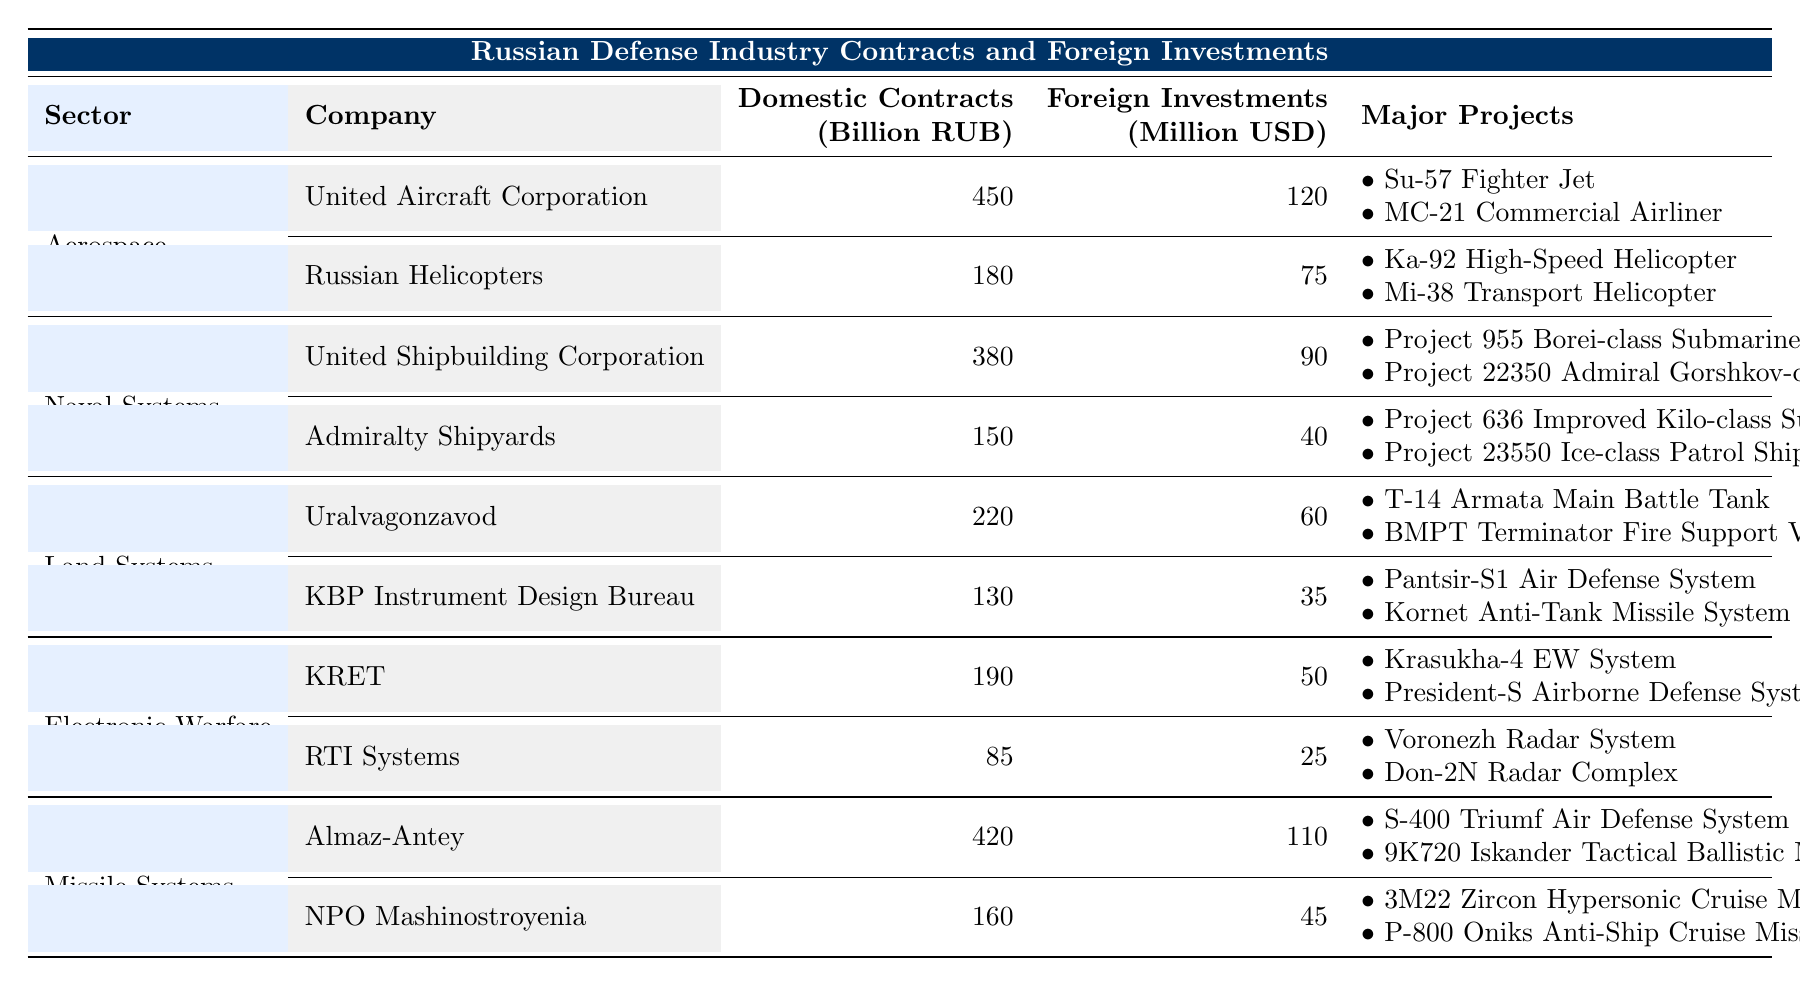What is the total amount of domestic contracts for the Aerospace sector? The domestic contracts for the Aerospace sector are the sum of the contracts for United Aircraft Corporation (450 billion RUB) and Russian Helicopters (180 billion RUB). Therefore, the total is 450 + 180 = 630 billion RUB.
Answer: 630 billion RUB Which company in the Missile Systems sector has the highest foreign investments? Comparing the foreign investments for both companies in the Missile Systems sector, Almaz-Antey has 110 million USD and NPO Mashinostroyenia has 45 million USD. Almaz-Antey has the highest amount.
Answer: Almaz-Antey What is the average amount of domestic contracts across all sectors? To find the average, we first calculate the total domestic contracts: 450 + 180 + 380 + 150 + 220 + 130 + 190 + 85 + 420 + 160 = 1,975 billion RUB. There are 10 companies, so the average is 1,975 / 10 = 197.5 billion RUB.
Answer: 197.5 billion RUB Does the Land Systems sector have more total domestic contracts than the Naval Systems sector? The total domestic contracts for Land Systems (Uralvagonzavod + KBP Instrument Design Bureau) is 220 + 130 = 350 billion RUB, while for Naval Systems (United Shipbuilding Corporation + Admiralty Shipyards) it is 380 + 150 = 530 billion RUB. Therefore, Land Systems does not have more total domestic contracts.
Answer: No What is the total amount of foreign investments in the Electronic Warfare sector? The foreign investments in the Electronic Warfare sector are from KRET (50 million USD) and RTI Systems (25 million USD). Adding these, we get 50 + 25 = 75 million USD as the total.
Answer: 75 million USD How much higher are the total domestic contracts in the Missile Systems sector compared to the Aerospace sector? The total domestic contracts in the Missile Systems sector are 420 (Almaz-Antey) + 160 (NPO Mashinostroyenia) = 580 billion RUB. For the Aerospace sector, it is 450 (United Aircraft Corporation) + 180 (Russian Helicopters) = 630 billion RUB. The difference is 630 - 580 = 50 billion RUB.
Answer: 50 billion RUB Which sector has the lowest total foreign investments, and what is that amount? The foreign investments for each sector are: Aerospace (195 million USD), Naval Systems (130 million USD), Land Systems (95 million USD), Electronic Warfare (75 million USD), and Missile Systems (155 million USD). The Electronic Warfare sector has the lowest foreign investments totaling 75 million USD.
Answer: Electronic Warfare, 75 million USD Is the total domestic contracts for Uralvagonzavod less than that for the United Shipbuilding Corporation? Uralvagonzavod has domestic contracts of 220 billion RUB, while United Shipbuilding Corporation has 380 billion RUB. Since 220 is less than 380, the statement is true.
Answer: Yes What is the sum of foreign investments from both companies in the Naval Systems sector? The foreign investments in the Naval Systems sector are 90 million USD (United Shipbuilding Corporation) and 40 million USD (Admiralty Shipyards). Adding these amounts gives 90 + 40 = 130 million USD.
Answer: 130 million USD 